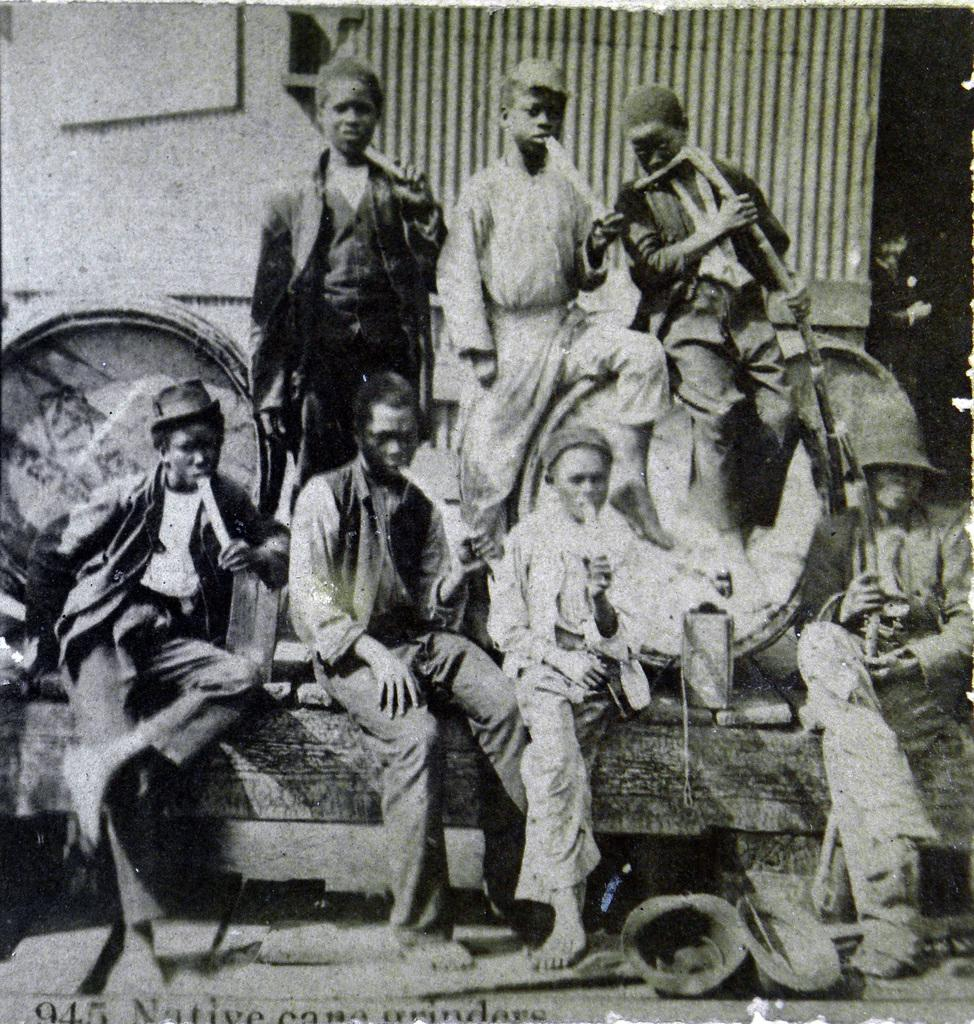What is the color scheme of the image? The image is black and white. What can be seen in the image? There are persons in the image. What are the persons wearing? The persons are wearing hats. What is visible in the background of the image? There is a wall in the background of the image. What type of notebook is being used by the persons in the image? There is no notebook present in the image; it is a black and white image featuring persons wearing hats with a wall in the background. What kind of meal is being prepared by the persons in the image? There is no meal preparation or indication of a meal in the image; it only shows persons wearing hats with a wall in the background. 